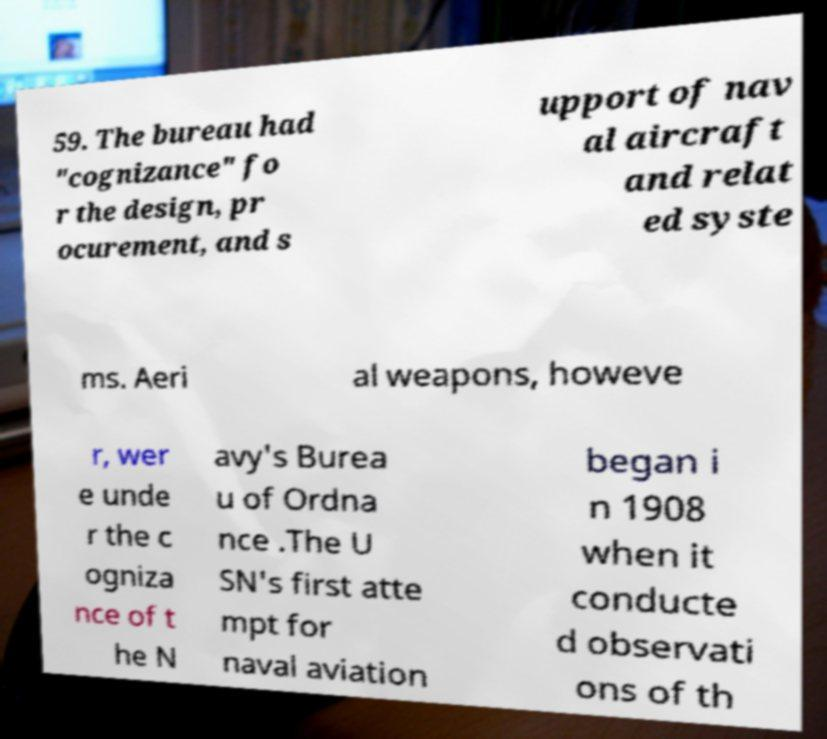Can you accurately transcribe the text from the provided image for me? 59. The bureau had "cognizance" fo r the design, pr ocurement, and s upport of nav al aircraft and relat ed syste ms. Aeri al weapons, howeve r, wer e unde r the c ogniza nce of t he N avy's Burea u of Ordna nce .The U SN's first atte mpt for naval aviation began i n 1908 when it conducte d observati ons of th 